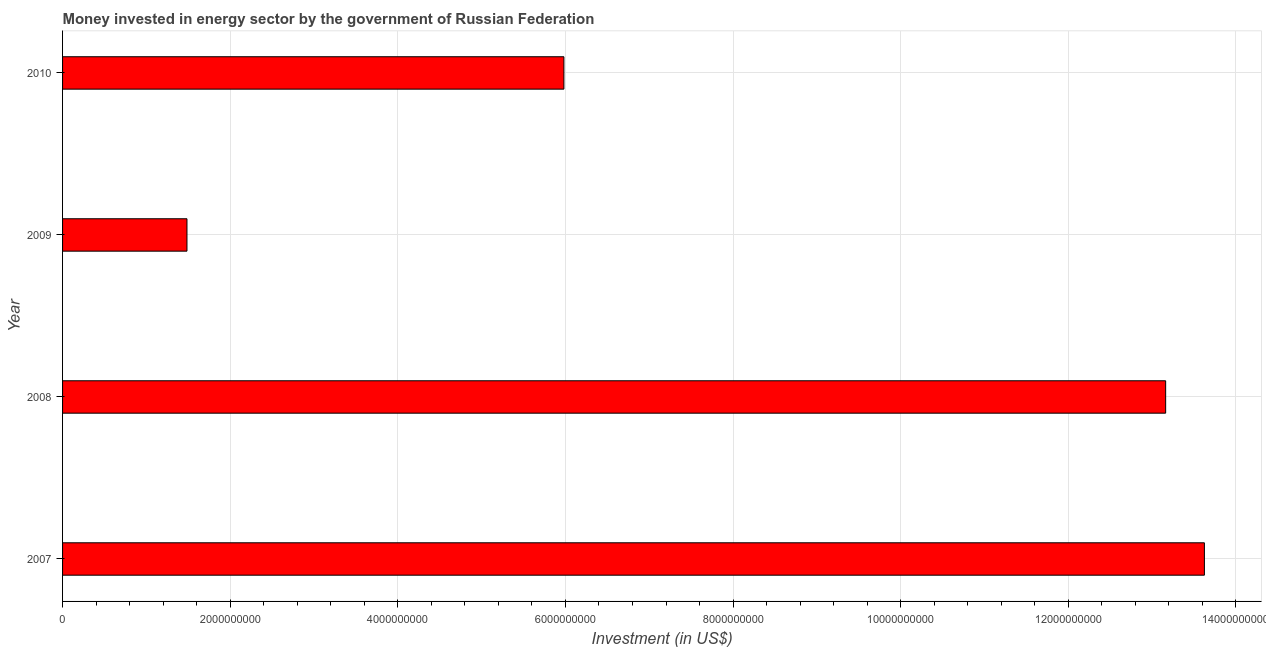Does the graph contain any zero values?
Keep it short and to the point. No. What is the title of the graph?
Make the answer very short. Money invested in energy sector by the government of Russian Federation. What is the label or title of the X-axis?
Your response must be concise. Investment (in US$). What is the investment in energy in 2009?
Your response must be concise. 1.48e+09. Across all years, what is the maximum investment in energy?
Provide a short and direct response. 1.36e+1. Across all years, what is the minimum investment in energy?
Provide a succinct answer. 1.48e+09. What is the sum of the investment in energy?
Make the answer very short. 3.43e+1. What is the difference between the investment in energy in 2008 and 2009?
Your answer should be very brief. 1.17e+1. What is the average investment in energy per year?
Ensure brevity in your answer.  8.56e+09. What is the median investment in energy?
Ensure brevity in your answer.  9.57e+09. Do a majority of the years between 2008 and 2010 (inclusive) have investment in energy greater than 7600000000 US$?
Your answer should be very brief. No. What is the ratio of the investment in energy in 2007 to that in 2010?
Provide a succinct answer. 2.28. What is the difference between the highest and the second highest investment in energy?
Your response must be concise. 4.62e+08. Is the sum of the investment in energy in 2009 and 2010 greater than the maximum investment in energy across all years?
Your answer should be very brief. No. What is the difference between the highest and the lowest investment in energy?
Give a very brief answer. 1.21e+1. How many bars are there?
Offer a very short reply. 4. Are all the bars in the graph horizontal?
Provide a short and direct response. Yes. How many years are there in the graph?
Ensure brevity in your answer.  4. What is the Investment (in US$) in 2007?
Ensure brevity in your answer.  1.36e+1. What is the Investment (in US$) of 2008?
Your answer should be very brief. 1.32e+1. What is the Investment (in US$) of 2009?
Your answer should be compact. 1.48e+09. What is the Investment (in US$) in 2010?
Ensure brevity in your answer.  5.98e+09. What is the difference between the Investment (in US$) in 2007 and 2008?
Ensure brevity in your answer.  4.62e+08. What is the difference between the Investment (in US$) in 2007 and 2009?
Keep it short and to the point. 1.21e+1. What is the difference between the Investment (in US$) in 2007 and 2010?
Your response must be concise. 7.64e+09. What is the difference between the Investment (in US$) in 2008 and 2009?
Offer a terse response. 1.17e+1. What is the difference between the Investment (in US$) in 2008 and 2010?
Your answer should be very brief. 7.18e+09. What is the difference between the Investment (in US$) in 2009 and 2010?
Provide a succinct answer. -4.50e+09. What is the ratio of the Investment (in US$) in 2007 to that in 2008?
Ensure brevity in your answer.  1.03. What is the ratio of the Investment (in US$) in 2007 to that in 2009?
Offer a very short reply. 9.18. What is the ratio of the Investment (in US$) in 2007 to that in 2010?
Ensure brevity in your answer.  2.28. What is the ratio of the Investment (in US$) in 2008 to that in 2009?
Ensure brevity in your answer.  8.87. What is the ratio of the Investment (in US$) in 2008 to that in 2010?
Give a very brief answer. 2.2. What is the ratio of the Investment (in US$) in 2009 to that in 2010?
Offer a very short reply. 0.25. 